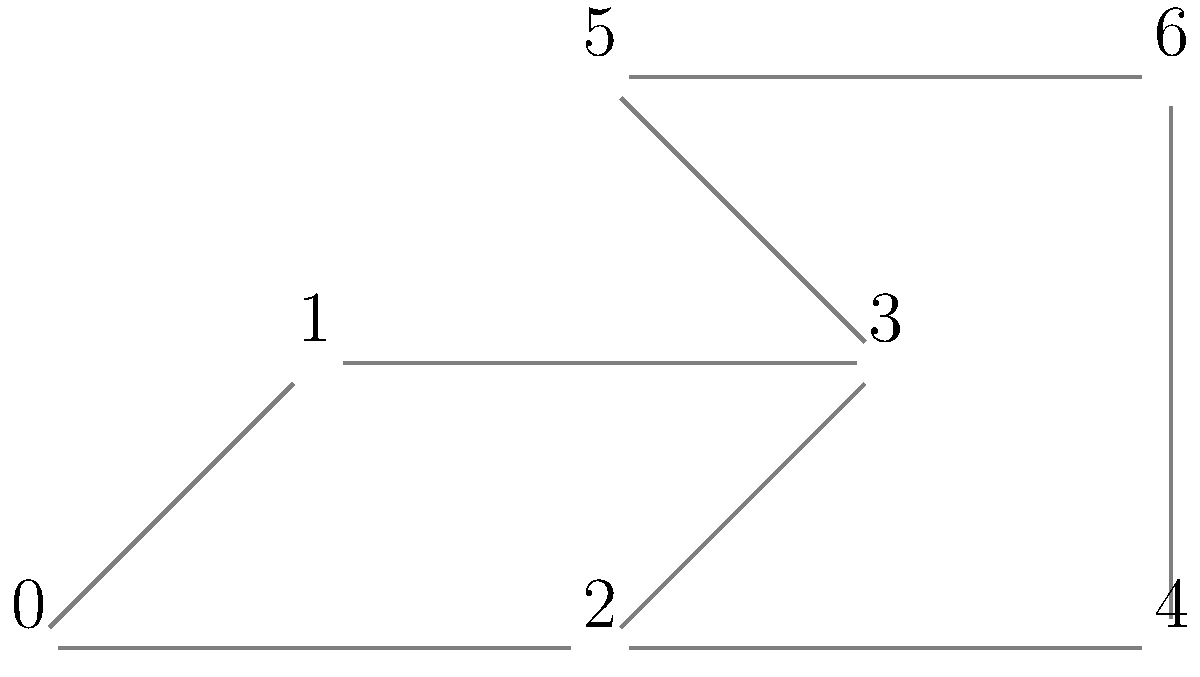In this fragmented family tree represented as a network graph, each node represents a person, and edges represent direct family relationships. If node 0 represents the oldest known ancestor, what is the minimum number of generations represented in this family tree? To determine the minimum number of generations in this family tree, we need to find the longest path from the oldest ancestor (node 0) to any leaf node. Here's how we can approach this:

1. Start at node 0 (the oldest ancestor).
2. Trace all possible paths from node 0 to the leaf nodes:
   - Path 1: 0 -> 1 -> 3 -> 5
   - Path 2: 0 -> 1 -> 3
   - Path 3: 0 -> 2 -> 3 -> 5
   - Path 4: 0 -> 2 -> 3
   - Path 5: 0 -> 2 -> 4 -> 6
   - Path 6: 0 -> 2 -> 4

3. Count the number of edges in each path:
   - Path 1: 3 edges
   - Path 2: 2 edges
   - Path 3: 3 edges
   - Path 4: 2 edges
   - Path 5: 3 edges
   - Path 6: 2 edges

4. The longest path has 3 edges, which represents 3 generations of descendants from the oldest ancestor.

5. Including the oldest ancestor (node 0), we have a total of 4 generations represented in this family tree.

Therefore, the minimum number of generations represented in this family tree is 4.
Answer: 4 generations 